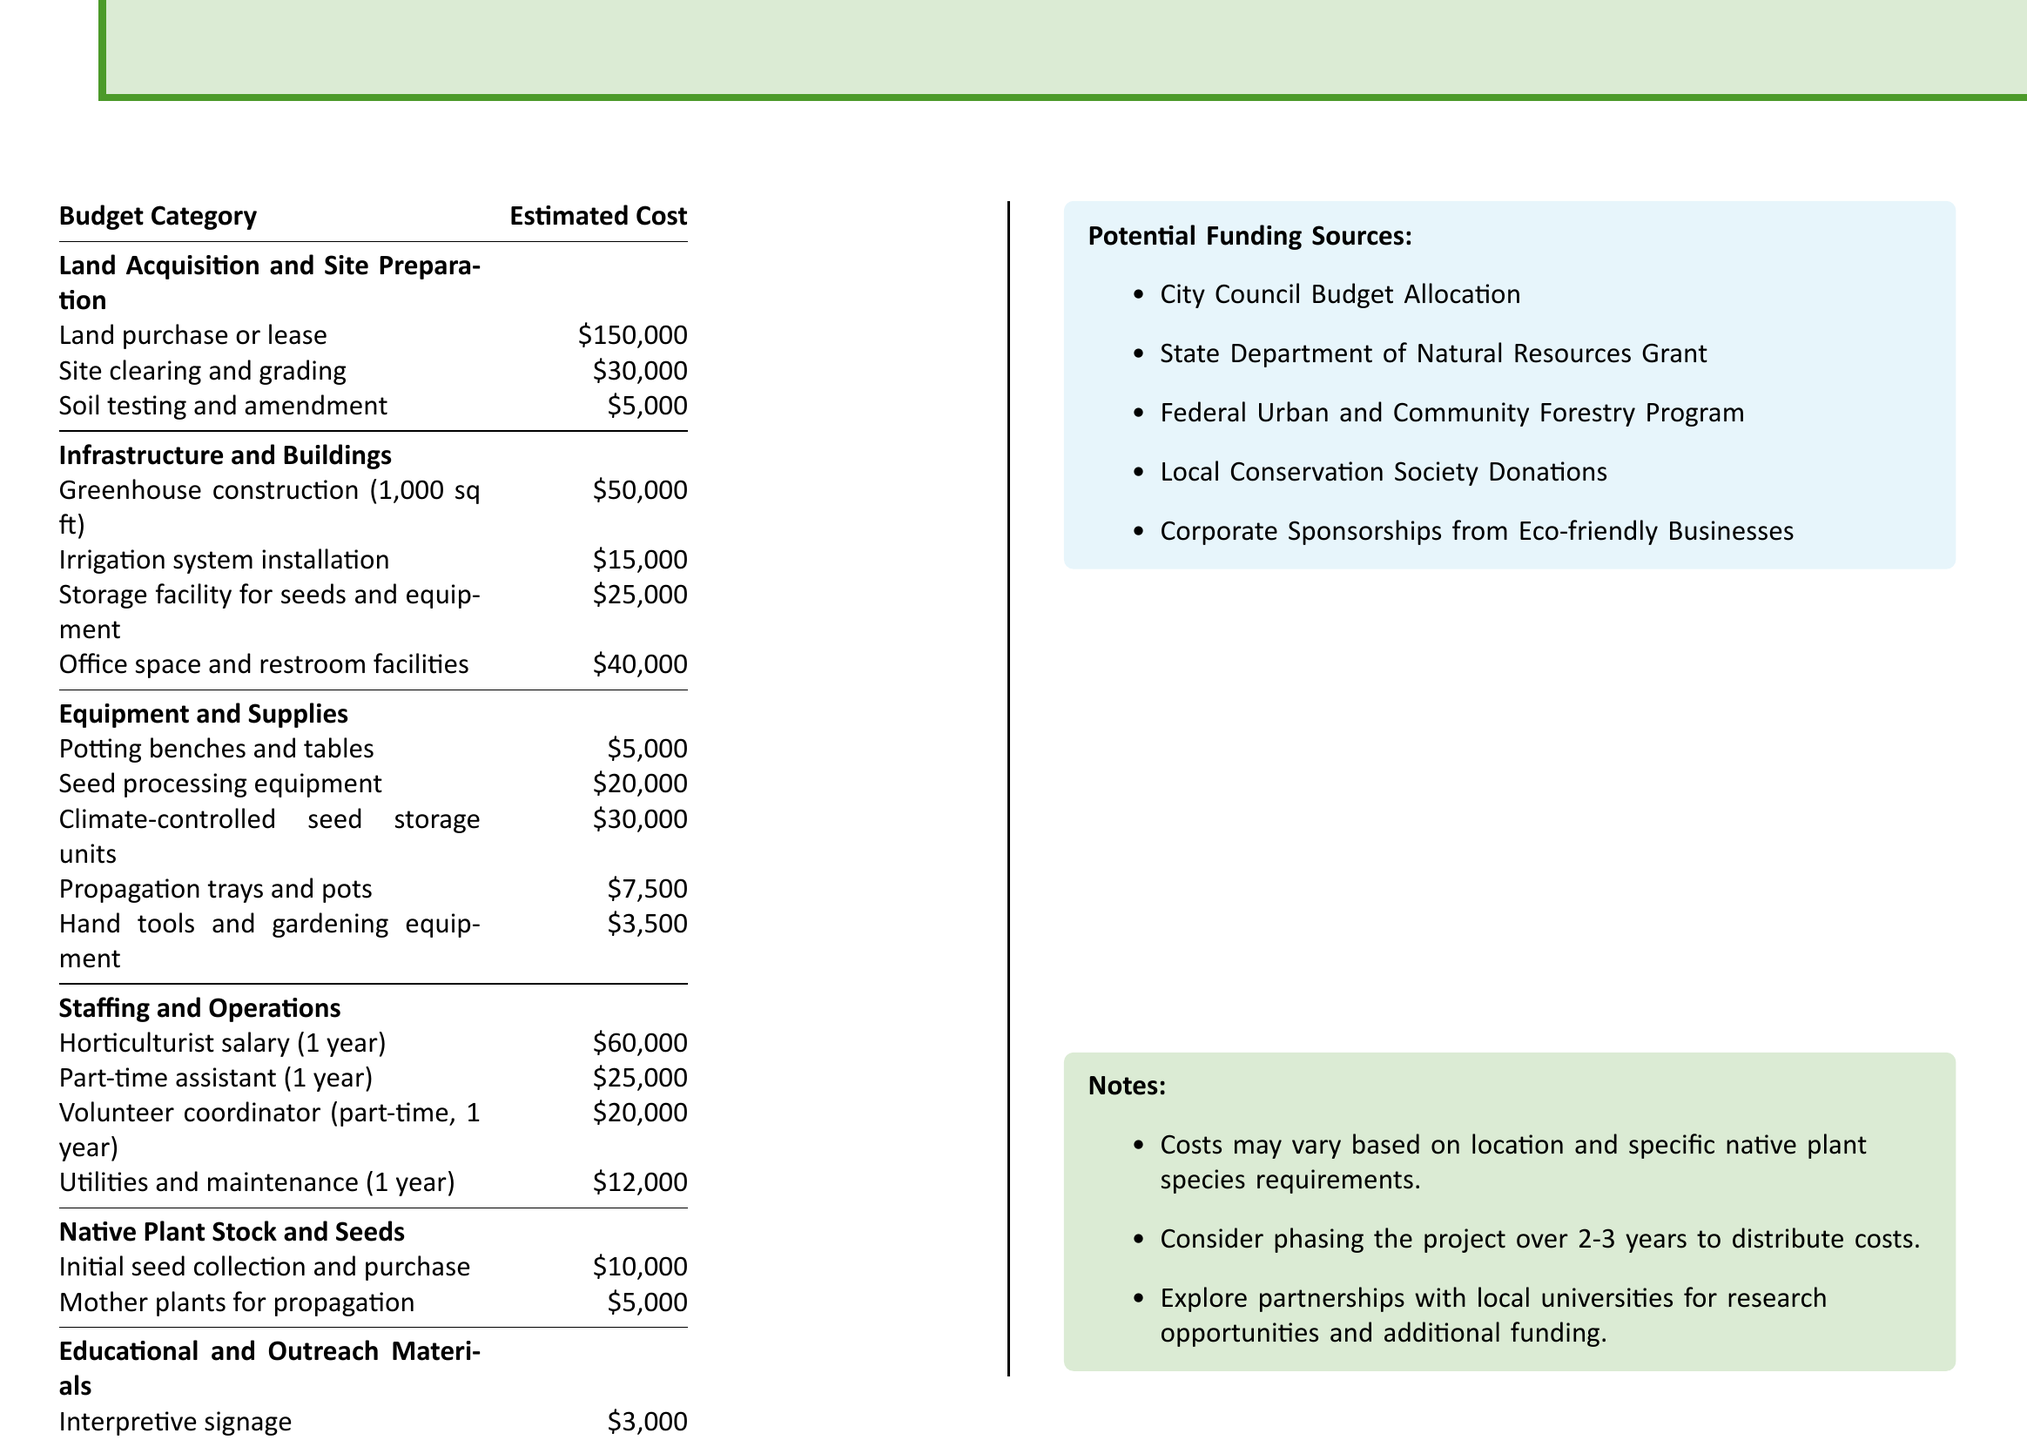What is the estimated cost for land acquisition and site preparation? The land acquisition and site preparation costs are detailed in the budget under that category, totaling $185,000.
Answer: $185,000 How much is required for greenhouse construction? The budget specifies $50,000 for constructing the greenhouse, which is a significant component of infrastructure.
Answer: $50,000 What is the total estimated cost for the project? The total estimated cost is stated at the end of the budget, which is the sum of all categories listed.
Answer: $523,000 How much will staffing for the horticulturist cost for one year? The budget lists the horticulturist's salary for one year as $60,000, which is a key staffing expense.
Answer: $60,000 Which category includes the costs for irrigation system installation? The irrigation system installation costs are specifically included in the Infrastructure and Buildings category.
Answer: Infrastructure and Buildings What potential funding source is provided for partnerships? The document mentions the potential for partnerships with local universities, suggesting a collaborative funding opportunity.
Answer: Local universities How much will be spent on educational handouts? The budget specifies the cost for brochures and educational handouts as $2,000 within the Educational and Outreach Materials category.
Answer: $2,000 What is the total estimated cost for native plant stock and seeds? The document lists the combined costs for initial seed collection and mother plants in the Native Plant Stock and Seeds category as $15,000.
Answer: $15,000 What utility costs are included in the annual staffing expenses? The utilities and maintenance costs are outlined in the Staffing and Operations section at $12,000 for one year.
Answer: $12,000 